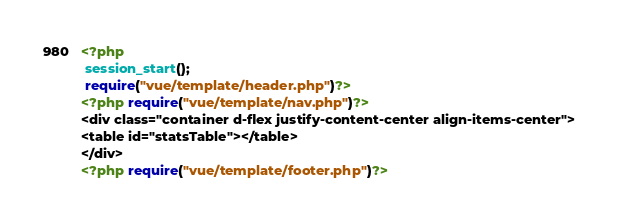Convert code to text. <code><loc_0><loc_0><loc_500><loc_500><_PHP_><?php
 session_start();
 require("vue/template/header.php")?>
<?php require("vue/template/nav.php")?>
<div class="container d-flex justify-content-center align-items-center">
<table id="statsTable"></table>
</div>
<?php require("vue/template/footer.php")?>
</code> 